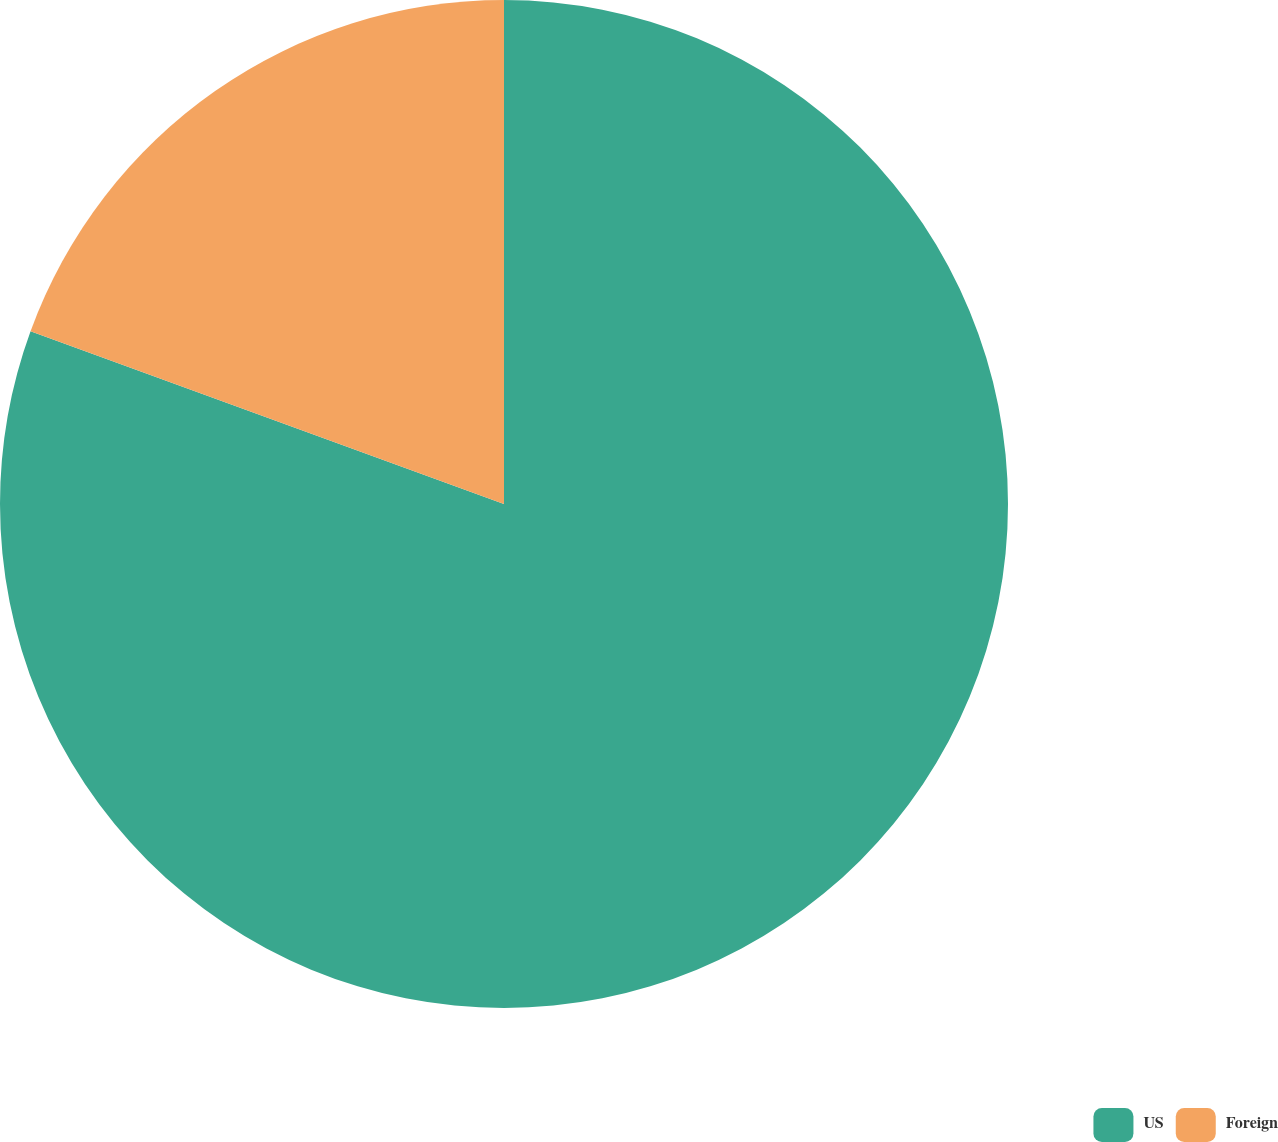<chart> <loc_0><loc_0><loc_500><loc_500><pie_chart><fcel>US<fcel>Foreign<nl><fcel>80.57%<fcel>19.43%<nl></chart> 